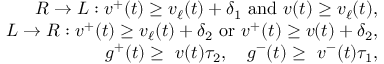<formula> <loc_0><loc_0><loc_500><loc_500>\begin{array} { r } { R \rightarrow L \colon v ^ { + } ( t ) \geq v _ { \ell } ( t ) + \delta _ { 1 } \ a n d \ v ( t ) \geq v _ { \ell } ( t ) , } \\ { L \rightarrow R \colon v ^ { + } ( t ) \geq v _ { \ell } ( t ) + \delta _ { 2 } \ o r \ v ^ { + } ( t ) \geq v ( t ) + \delta _ { 2 } , } \\ { g ^ { + } ( t ) \geq \ v ( t ) \tau _ { 2 } , \quad g ^ { - } ( t ) \geq \ v ^ { - } ( t ) \tau _ { 1 } , } \end{array}</formula> 